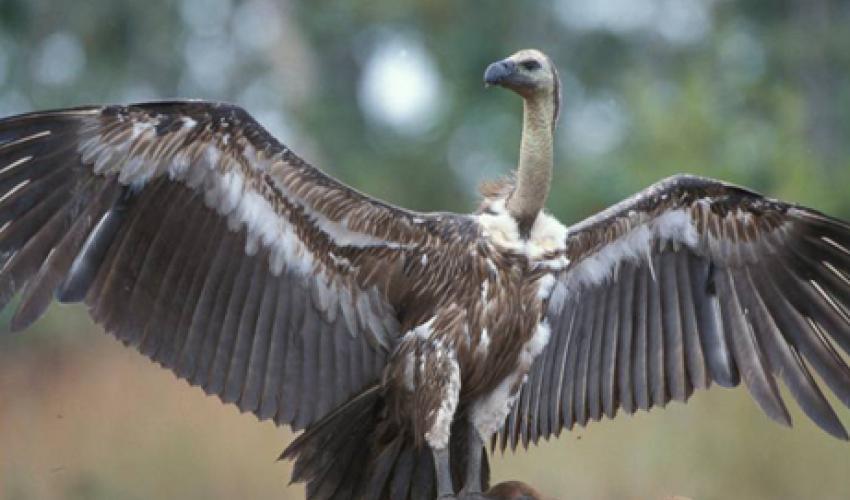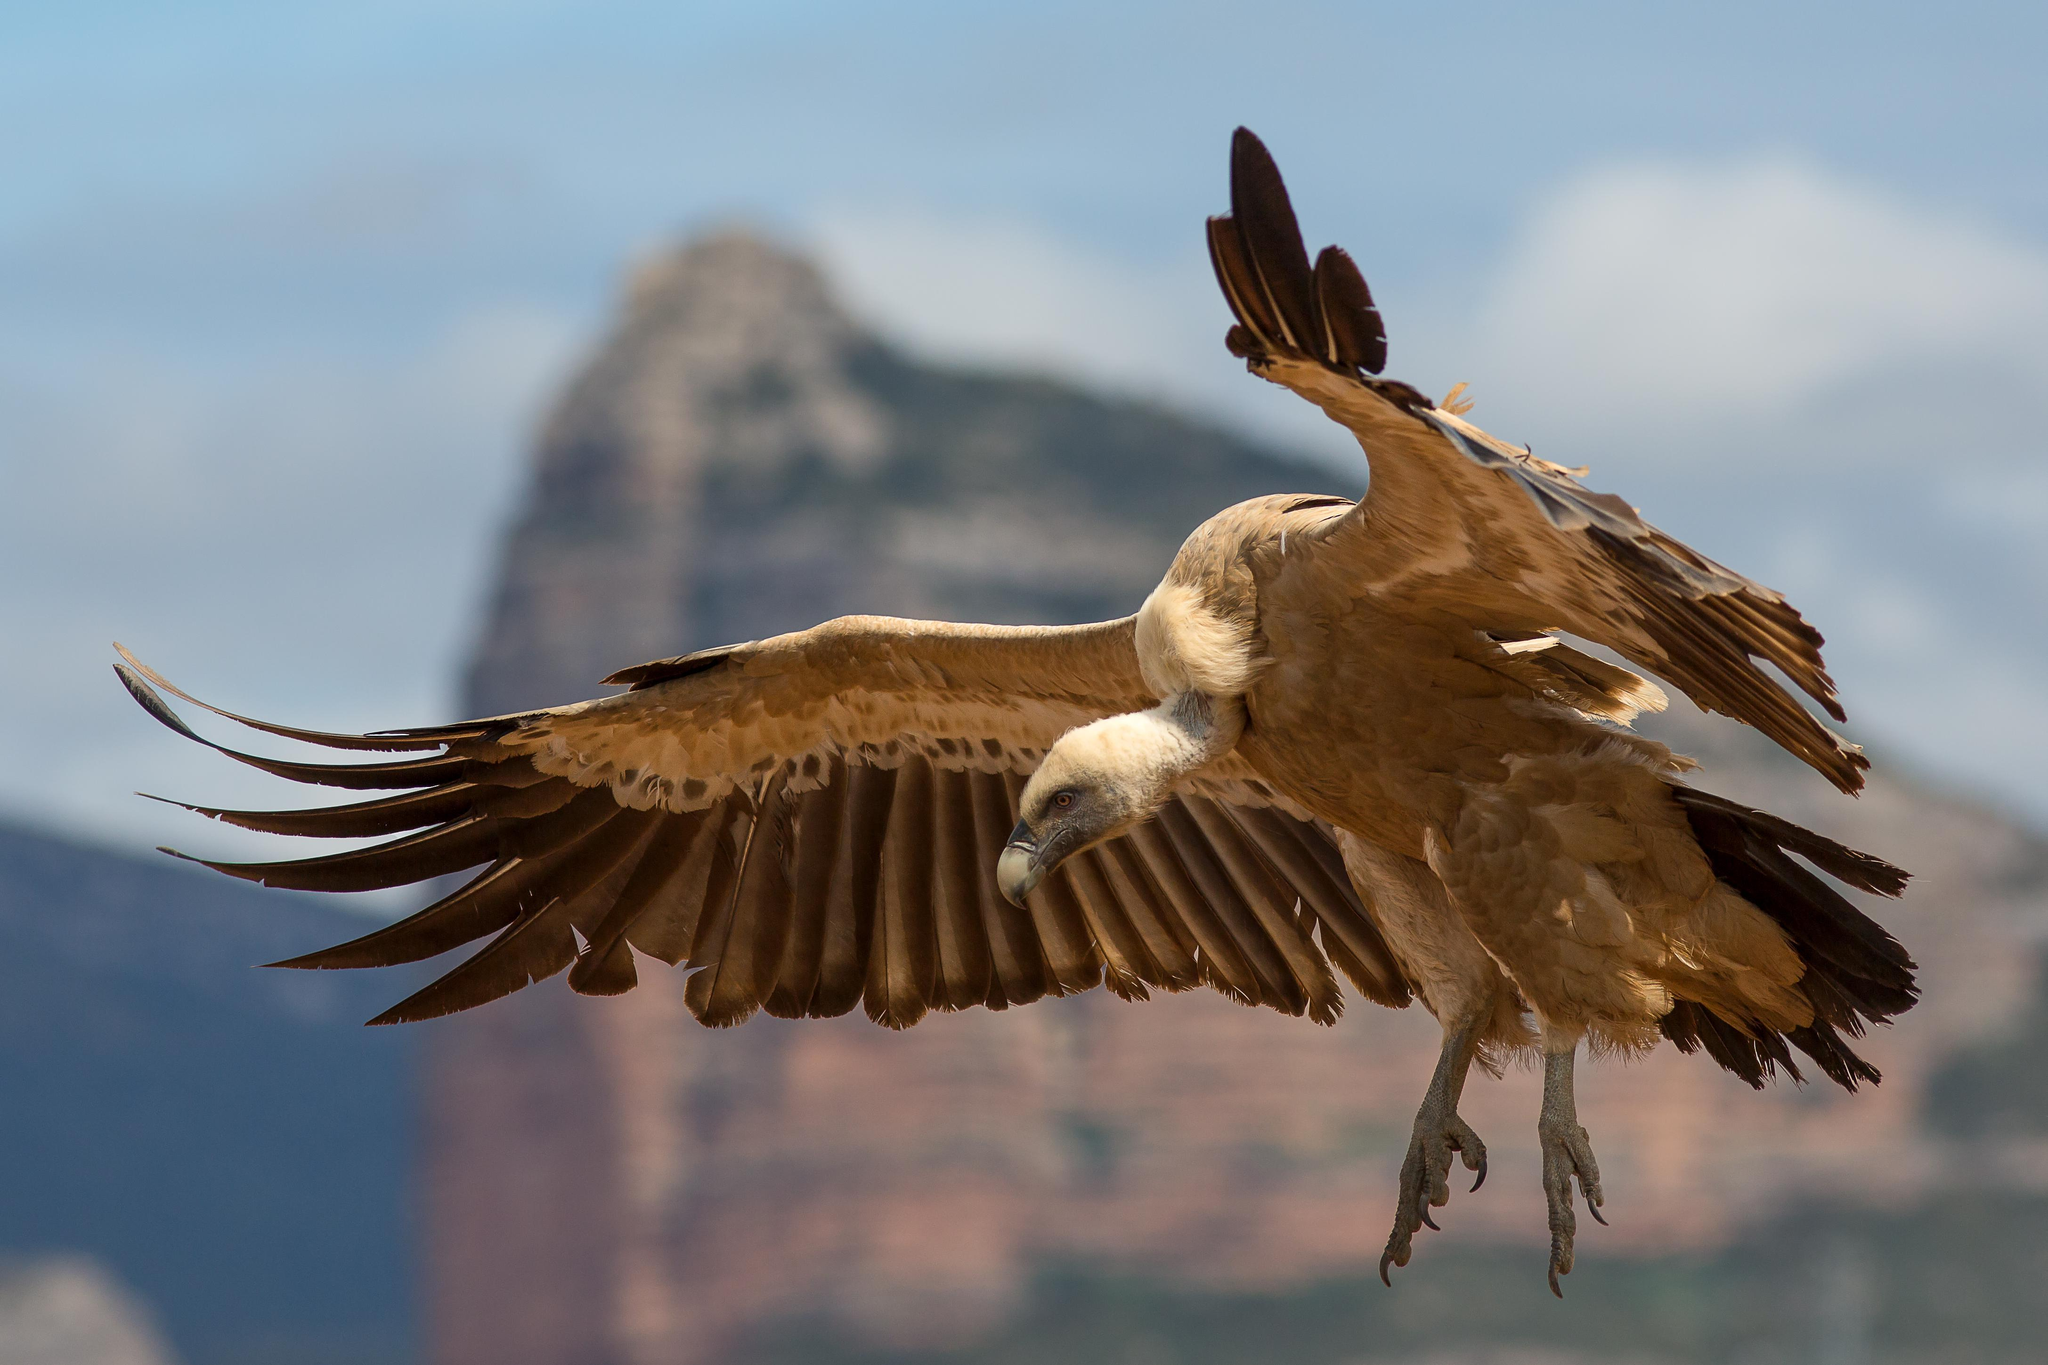The first image is the image on the left, the second image is the image on the right. Assess this claim about the two images: "The bird in the left image is looking towards the left.". Correct or not? Answer yes or no. Yes. The first image is the image on the left, the second image is the image on the right. Considering the images on both sides, is "An image shows one vulture with outspread wings, but it is not in flight off the ground." valid? Answer yes or no. Yes. 